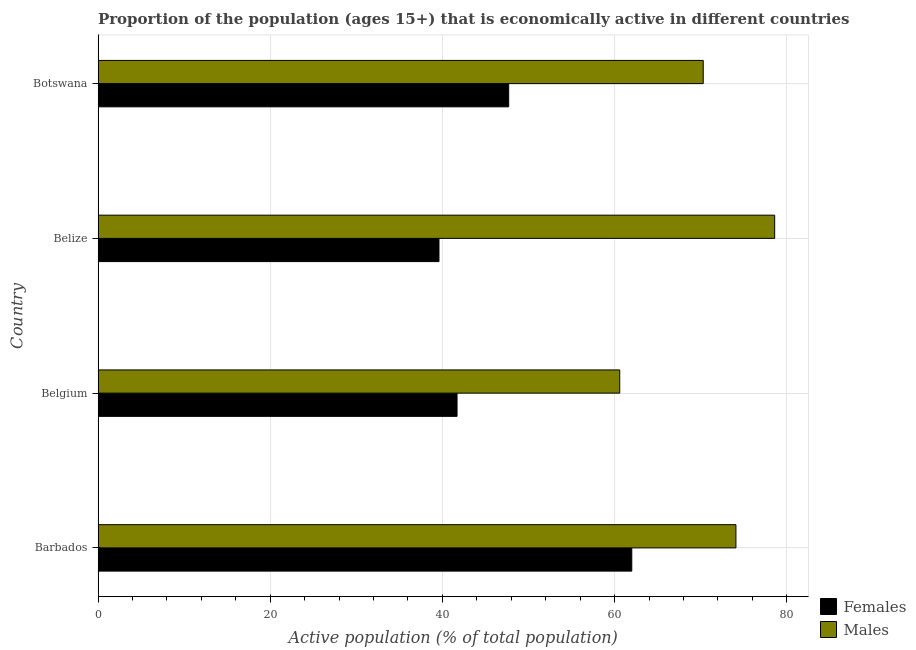How many different coloured bars are there?
Your answer should be very brief. 2. How many groups of bars are there?
Keep it short and to the point. 4. Are the number of bars per tick equal to the number of legend labels?
Ensure brevity in your answer.  Yes. Are the number of bars on each tick of the Y-axis equal?
Ensure brevity in your answer.  Yes. How many bars are there on the 4th tick from the bottom?
Give a very brief answer. 2. What is the label of the 2nd group of bars from the top?
Your answer should be very brief. Belize. What is the percentage of economically active male population in Belize?
Provide a succinct answer. 78.6. Across all countries, what is the maximum percentage of economically active female population?
Make the answer very short. 62. Across all countries, what is the minimum percentage of economically active male population?
Make the answer very short. 60.6. In which country was the percentage of economically active female population maximum?
Give a very brief answer. Barbados. In which country was the percentage of economically active female population minimum?
Offer a terse response. Belize. What is the total percentage of economically active female population in the graph?
Your answer should be very brief. 191. What is the difference between the percentage of economically active male population in Botswana and the percentage of economically active female population in Belgium?
Provide a short and direct response. 28.6. What is the average percentage of economically active female population per country?
Offer a terse response. 47.75. What is the difference between the percentage of economically active female population and percentage of economically active male population in Belize?
Provide a short and direct response. -39. In how many countries, is the percentage of economically active male population greater than 48 %?
Your answer should be compact. 4. What is the ratio of the percentage of economically active female population in Belgium to that in Botswana?
Provide a short and direct response. 0.87. What is the difference between the highest and the lowest percentage of economically active male population?
Your answer should be compact. 18. Is the sum of the percentage of economically active male population in Belize and Botswana greater than the maximum percentage of economically active female population across all countries?
Give a very brief answer. Yes. What does the 2nd bar from the top in Belize represents?
Offer a terse response. Females. What does the 2nd bar from the bottom in Belize represents?
Your answer should be compact. Males. How many countries are there in the graph?
Your answer should be compact. 4. Does the graph contain any zero values?
Offer a terse response. No. How are the legend labels stacked?
Keep it short and to the point. Vertical. What is the title of the graph?
Make the answer very short. Proportion of the population (ages 15+) that is economically active in different countries. Does "Time to import" appear as one of the legend labels in the graph?
Ensure brevity in your answer.  No. What is the label or title of the X-axis?
Offer a very short reply. Active population (% of total population). What is the Active population (% of total population) in Males in Barbados?
Ensure brevity in your answer.  74.1. What is the Active population (% of total population) in Females in Belgium?
Provide a short and direct response. 41.7. What is the Active population (% of total population) in Males in Belgium?
Give a very brief answer. 60.6. What is the Active population (% of total population) of Females in Belize?
Ensure brevity in your answer.  39.6. What is the Active population (% of total population) in Males in Belize?
Your response must be concise. 78.6. What is the Active population (% of total population) of Females in Botswana?
Provide a succinct answer. 47.7. What is the Active population (% of total population) of Males in Botswana?
Offer a terse response. 70.3. Across all countries, what is the maximum Active population (% of total population) of Females?
Provide a succinct answer. 62. Across all countries, what is the maximum Active population (% of total population) in Males?
Your answer should be compact. 78.6. Across all countries, what is the minimum Active population (% of total population) in Females?
Your answer should be very brief. 39.6. Across all countries, what is the minimum Active population (% of total population) in Males?
Provide a short and direct response. 60.6. What is the total Active population (% of total population) in Females in the graph?
Your answer should be compact. 191. What is the total Active population (% of total population) of Males in the graph?
Offer a very short reply. 283.6. What is the difference between the Active population (% of total population) of Females in Barbados and that in Belgium?
Keep it short and to the point. 20.3. What is the difference between the Active population (% of total population) in Males in Barbados and that in Belgium?
Provide a succinct answer. 13.5. What is the difference between the Active population (% of total population) of Females in Barbados and that in Belize?
Make the answer very short. 22.4. What is the difference between the Active population (% of total population) of Males in Barbados and that in Botswana?
Provide a succinct answer. 3.8. What is the difference between the Active population (% of total population) of Females in Barbados and the Active population (% of total population) of Males in Belize?
Your answer should be very brief. -16.6. What is the difference between the Active population (% of total population) in Females in Barbados and the Active population (% of total population) in Males in Botswana?
Make the answer very short. -8.3. What is the difference between the Active population (% of total population) of Females in Belgium and the Active population (% of total population) of Males in Belize?
Your response must be concise. -36.9. What is the difference between the Active population (% of total population) of Females in Belgium and the Active population (% of total population) of Males in Botswana?
Keep it short and to the point. -28.6. What is the difference between the Active population (% of total population) in Females in Belize and the Active population (% of total population) in Males in Botswana?
Offer a terse response. -30.7. What is the average Active population (% of total population) of Females per country?
Offer a very short reply. 47.75. What is the average Active population (% of total population) in Males per country?
Ensure brevity in your answer.  70.9. What is the difference between the Active population (% of total population) in Females and Active population (% of total population) in Males in Belgium?
Ensure brevity in your answer.  -18.9. What is the difference between the Active population (% of total population) of Females and Active population (% of total population) of Males in Belize?
Provide a succinct answer. -39. What is the difference between the Active population (% of total population) in Females and Active population (% of total population) in Males in Botswana?
Make the answer very short. -22.6. What is the ratio of the Active population (% of total population) in Females in Barbados to that in Belgium?
Provide a succinct answer. 1.49. What is the ratio of the Active population (% of total population) of Males in Barbados to that in Belgium?
Provide a short and direct response. 1.22. What is the ratio of the Active population (% of total population) in Females in Barbados to that in Belize?
Keep it short and to the point. 1.57. What is the ratio of the Active population (% of total population) in Males in Barbados to that in Belize?
Offer a terse response. 0.94. What is the ratio of the Active population (% of total population) in Females in Barbados to that in Botswana?
Your answer should be very brief. 1.3. What is the ratio of the Active population (% of total population) of Males in Barbados to that in Botswana?
Provide a succinct answer. 1.05. What is the ratio of the Active population (% of total population) of Females in Belgium to that in Belize?
Your answer should be very brief. 1.05. What is the ratio of the Active population (% of total population) of Males in Belgium to that in Belize?
Your response must be concise. 0.77. What is the ratio of the Active population (% of total population) of Females in Belgium to that in Botswana?
Give a very brief answer. 0.87. What is the ratio of the Active population (% of total population) in Males in Belgium to that in Botswana?
Keep it short and to the point. 0.86. What is the ratio of the Active population (% of total population) of Females in Belize to that in Botswana?
Provide a succinct answer. 0.83. What is the ratio of the Active population (% of total population) of Males in Belize to that in Botswana?
Your response must be concise. 1.12. What is the difference between the highest and the second highest Active population (% of total population) in Females?
Make the answer very short. 14.3. What is the difference between the highest and the lowest Active population (% of total population) of Females?
Make the answer very short. 22.4. What is the difference between the highest and the lowest Active population (% of total population) of Males?
Give a very brief answer. 18. 